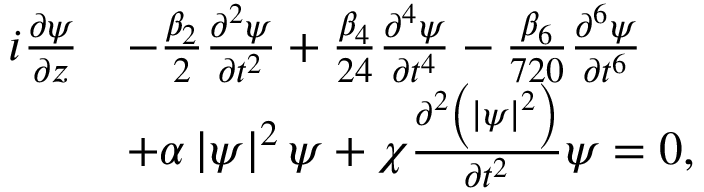Convert formula to latex. <formula><loc_0><loc_0><loc_500><loc_500>\begin{array} { r l } { i \frac { \partial \psi } { \partial z } } & { - \frac { \beta _ { 2 } } { 2 } \frac { \partial ^ { 2 } \psi } { \partial t ^ { 2 } } + \frac { \beta _ { 4 } } { 2 4 } \frac { \partial ^ { 4 } \psi } { \partial t ^ { 4 } } - \frac { \beta _ { 6 } } { 7 2 0 } \frac { \partial ^ { 6 } \psi } { \partial t ^ { 6 } } } \\ & { + \alpha \left | \psi \right | ^ { 2 } \psi + \chi \frac { \partial ^ { 2 } \left ( \left | \psi \right | ^ { 2 } \right ) } { \partial t ^ { 2 } } \psi = 0 , } \end{array}</formula> 